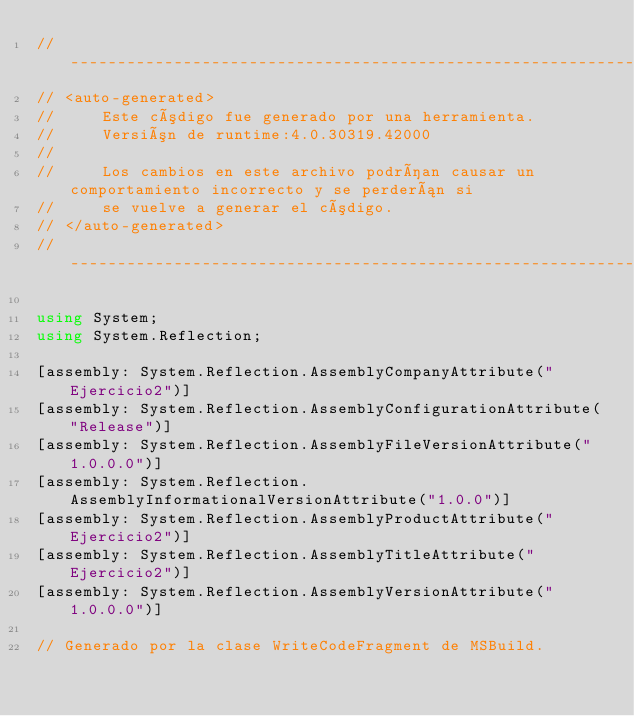Convert code to text. <code><loc_0><loc_0><loc_500><loc_500><_C#_>//------------------------------------------------------------------------------
// <auto-generated>
//     Este código fue generado por una herramienta.
//     Versión de runtime:4.0.30319.42000
//
//     Los cambios en este archivo podrían causar un comportamiento incorrecto y se perderán si
//     se vuelve a generar el código.
// </auto-generated>
//------------------------------------------------------------------------------

using System;
using System.Reflection;

[assembly: System.Reflection.AssemblyCompanyAttribute("Ejercicio2")]
[assembly: System.Reflection.AssemblyConfigurationAttribute("Release")]
[assembly: System.Reflection.AssemblyFileVersionAttribute("1.0.0.0")]
[assembly: System.Reflection.AssemblyInformationalVersionAttribute("1.0.0")]
[assembly: System.Reflection.AssemblyProductAttribute("Ejercicio2")]
[assembly: System.Reflection.AssemblyTitleAttribute("Ejercicio2")]
[assembly: System.Reflection.AssemblyVersionAttribute("1.0.0.0")]

// Generado por la clase WriteCodeFragment de MSBuild.

</code> 